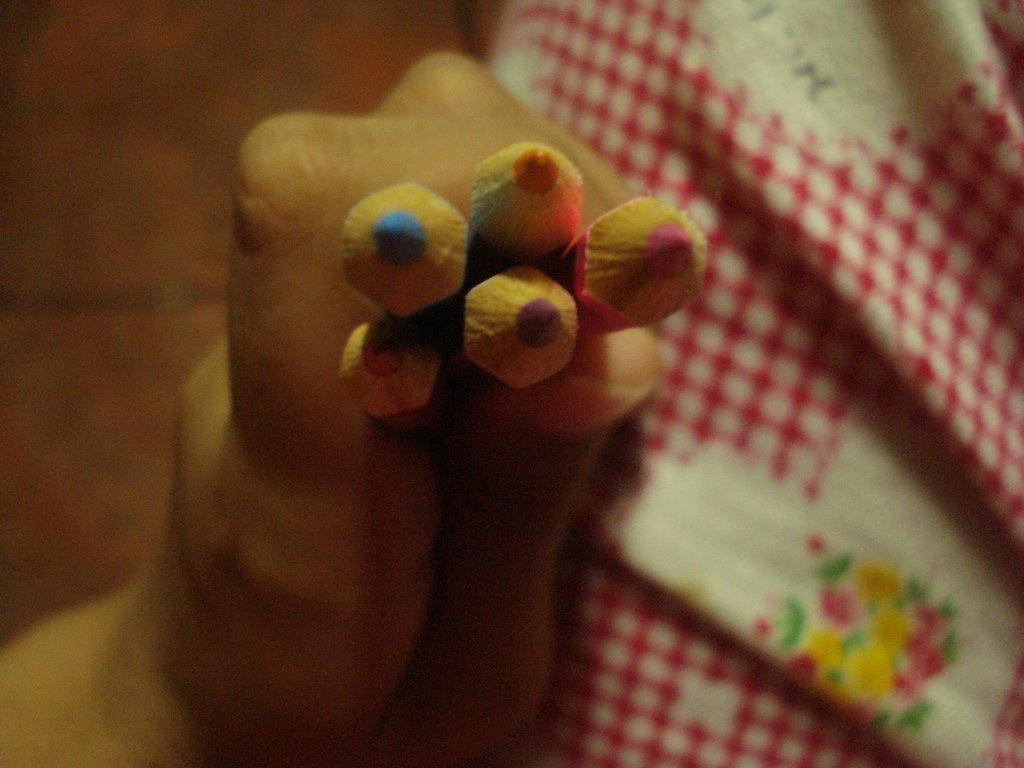What is happening in the image involving a person? The person is catching pencils with their hand. What else can be seen in the image besides the person? There is a cloth in the image. Can you describe the cloth in the image? The cloth has a design on it. What is the person's opinion on the door in the image? There is no door present in the image, so the person's opinion cannot be determined. 